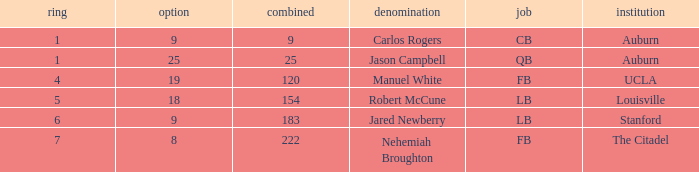Which college had an overall pick of 9? Auburn. 